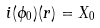<formula> <loc_0><loc_0><loc_500><loc_500>i ( \phi _ { 0 } ) ( r ) = X _ { 0 }</formula> 